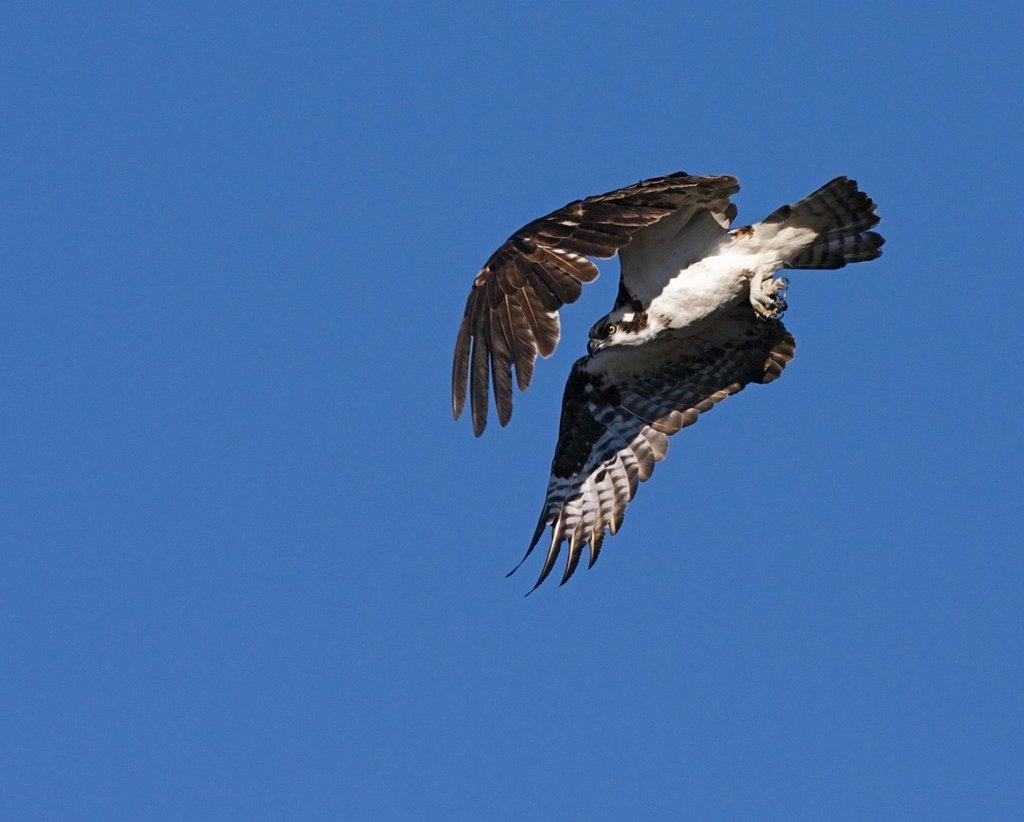What type of animal can be seen in the image? There is a bird in the image. What is the bird doing in the image? The bird is flying in the air. What can be seen in the background of the image? The sky is visible in the background of the image. How many frogs are sitting on the cloud in the image? There are no frogs or clouds present in the image; it features a bird flying in the sky. What event is taking place in the image related to birth? There is no event related to birth depicted in the image. 